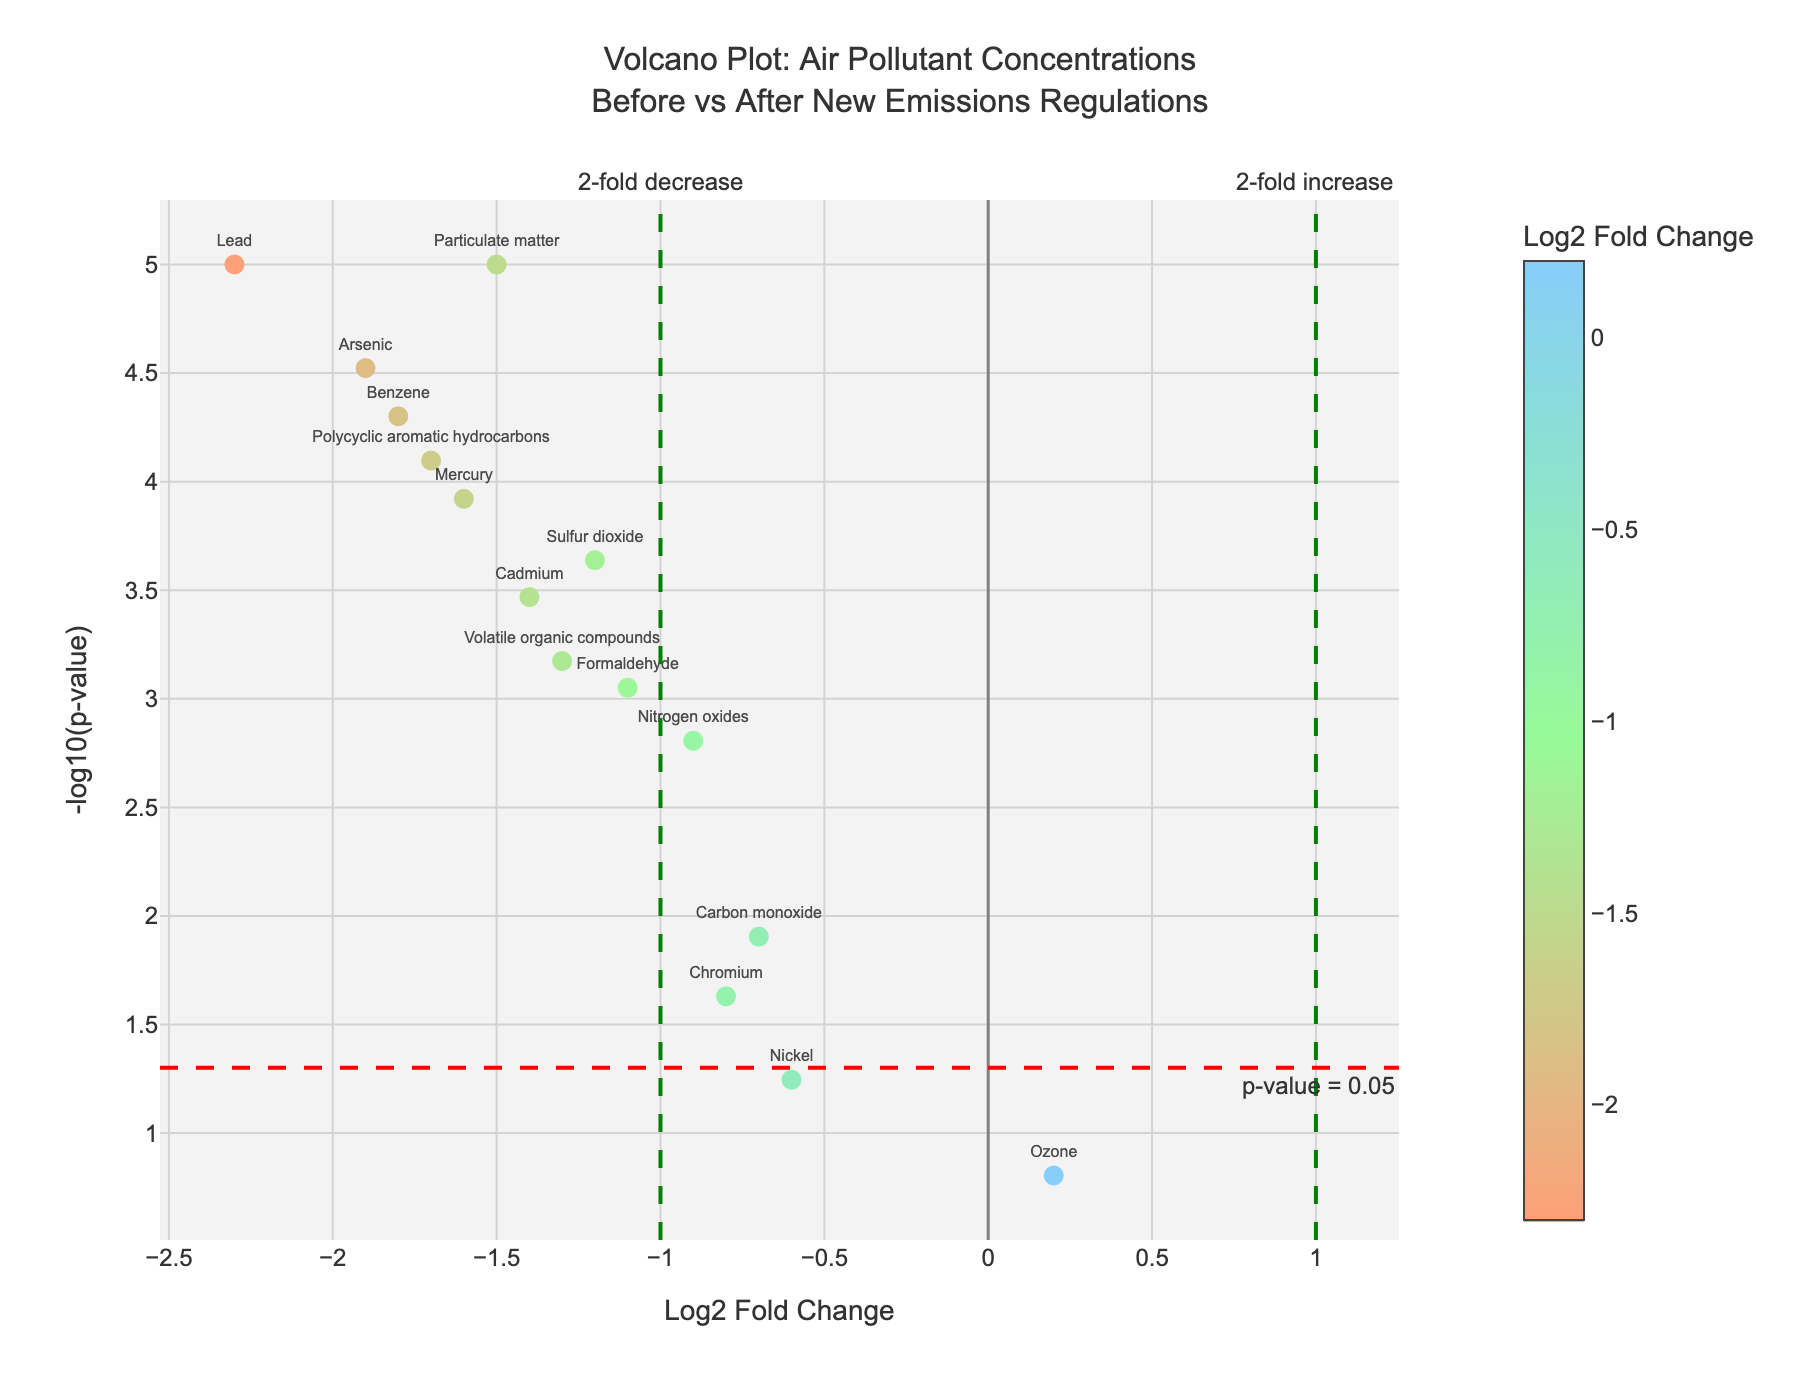What's the title of the plot? The title is located at the top of the figure. It is a textual representation that provides a summary of the data being visualized.
Answer: "Volcano Plot: Air Pollutant Concentrations Before vs After New Emissions Regulations" What does the x-axis represent? The x-axis label is found at the bottom of the plot. It represents the measure along the horizontal axis, indicating the direction and magnitude of change.
Answer: Log2 Fold Change What does the y-axis represent? The y-axis label is found on the left side of the plot. It represents the measure along the vertical axis, indicating the statistical significance of data points.
Answer: -log10(p-value) What do the data points with large positive y-values signify? Large positive values on the y-axis correspond to low p-values, indicating strong statistical significance. The higher the -log10(p-value), the more statistically significant the data point is.
Answer: Strong statistical significance How many compounds show a statistically significant decrease in concentration after the regulations (below -1 on the x-axis)? Count the data points to the left of the green vertical line at -1 and above the horizontal red dashed line indicating p = 0.05.
Answer: 8 Which compound shows the greatest decrease in concentration? Identify the data point with the most negative Log2 Fold Change value. The label near this point will indicate the compound.
Answer: Lead How many data points are above the p-value significance threshold (red horizontal dashed line at y = 1.30103)? Count all the data points above the horizontal red line.
Answer: 13 Which compound is closest to showing no change in concentration after the regulations? Look for the data point nearest to 0 on the x-axis, representing no fold change.
Answer: Ozone Which compound has the most negative Log2 Fold Change but is not statistically significant? Find the data point with the most negative Log2 Fold Change below the red horizontal dashed line (p-value threshold).
Answer: Chromium Are there any compounds that increased in concentration after the regulations with statistical significance? Check the right side of the plot (Log2 Fold Change > 0). Look for points above the red horizontal dashed line.
Answer: No 